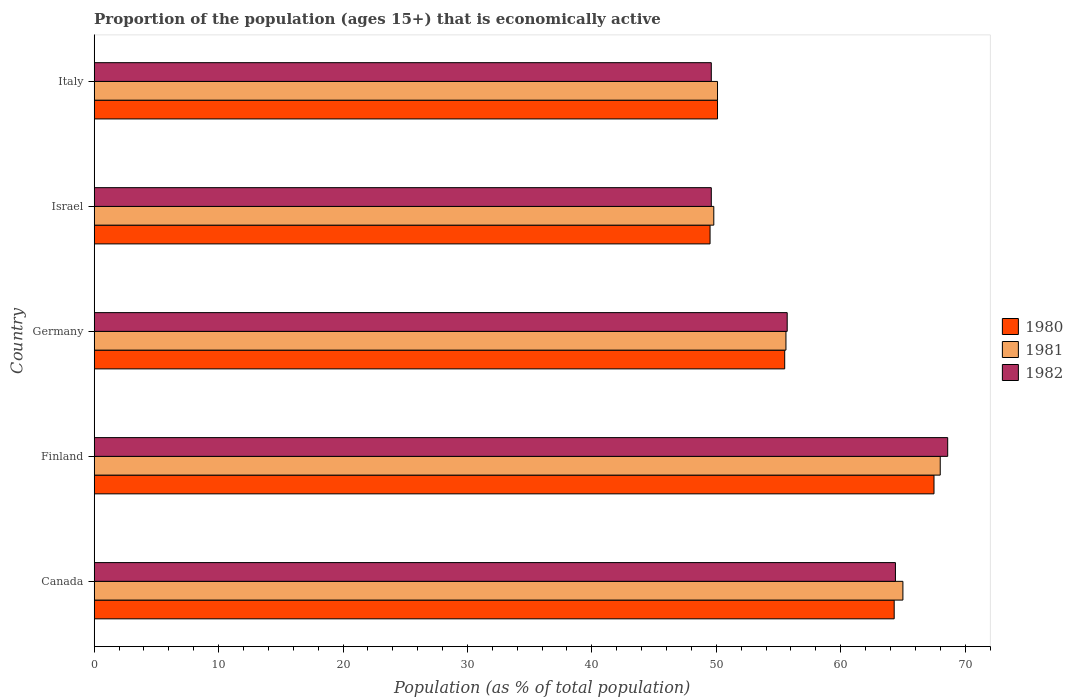How many groups of bars are there?
Provide a short and direct response. 5. Are the number of bars on each tick of the Y-axis equal?
Give a very brief answer. Yes. How many bars are there on the 4th tick from the top?
Offer a very short reply. 3. What is the label of the 1st group of bars from the top?
Keep it short and to the point. Italy. What is the proportion of the population that is economically active in 1980 in Israel?
Your response must be concise. 49.5. Across all countries, what is the minimum proportion of the population that is economically active in 1982?
Provide a succinct answer. 49.6. In which country was the proportion of the population that is economically active in 1980 maximum?
Provide a short and direct response. Finland. In which country was the proportion of the population that is economically active in 1981 minimum?
Make the answer very short. Israel. What is the total proportion of the population that is economically active in 1982 in the graph?
Make the answer very short. 287.9. What is the difference between the proportion of the population that is economically active in 1982 in Canada and the proportion of the population that is economically active in 1981 in Germany?
Your answer should be very brief. 8.8. What is the average proportion of the population that is economically active in 1981 per country?
Make the answer very short. 57.7. What is the difference between the proportion of the population that is economically active in 1982 and proportion of the population that is economically active in 1980 in Israel?
Ensure brevity in your answer.  0.1. What is the ratio of the proportion of the population that is economically active in 1981 in Finland to that in Israel?
Provide a succinct answer. 1.37. Is the difference between the proportion of the population that is economically active in 1982 in Germany and Italy greater than the difference between the proportion of the population that is economically active in 1980 in Germany and Italy?
Ensure brevity in your answer.  Yes. What is the difference between the highest and the second highest proportion of the population that is economically active in 1982?
Offer a very short reply. 4.2. What is the difference between the highest and the lowest proportion of the population that is economically active in 1982?
Keep it short and to the point. 19. How many bars are there?
Ensure brevity in your answer.  15. What is the difference between two consecutive major ticks on the X-axis?
Offer a very short reply. 10. Does the graph contain grids?
Provide a short and direct response. No. Where does the legend appear in the graph?
Make the answer very short. Center right. What is the title of the graph?
Make the answer very short. Proportion of the population (ages 15+) that is economically active. Does "2006" appear as one of the legend labels in the graph?
Offer a terse response. No. What is the label or title of the X-axis?
Offer a terse response. Population (as % of total population). What is the Population (as % of total population) in 1980 in Canada?
Offer a very short reply. 64.3. What is the Population (as % of total population) of 1982 in Canada?
Provide a short and direct response. 64.4. What is the Population (as % of total population) of 1980 in Finland?
Your answer should be very brief. 67.5. What is the Population (as % of total population) of 1981 in Finland?
Your answer should be very brief. 68. What is the Population (as % of total population) of 1982 in Finland?
Your answer should be compact. 68.6. What is the Population (as % of total population) of 1980 in Germany?
Your answer should be compact. 55.5. What is the Population (as % of total population) of 1981 in Germany?
Provide a succinct answer. 55.6. What is the Population (as % of total population) in 1982 in Germany?
Ensure brevity in your answer.  55.7. What is the Population (as % of total population) in 1980 in Israel?
Offer a very short reply. 49.5. What is the Population (as % of total population) in 1981 in Israel?
Offer a terse response. 49.8. What is the Population (as % of total population) of 1982 in Israel?
Offer a very short reply. 49.6. What is the Population (as % of total population) of 1980 in Italy?
Your response must be concise. 50.1. What is the Population (as % of total population) of 1981 in Italy?
Your answer should be compact. 50.1. What is the Population (as % of total population) in 1982 in Italy?
Offer a very short reply. 49.6. Across all countries, what is the maximum Population (as % of total population) in 1980?
Provide a short and direct response. 67.5. Across all countries, what is the maximum Population (as % of total population) of 1981?
Your answer should be very brief. 68. Across all countries, what is the maximum Population (as % of total population) in 1982?
Your answer should be compact. 68.6. Across all countries, what is the minimum Population (as % of total population) in 1980?
Your answer should be very brief. 49.5. Across all countries, what is the minimum Population (as % of total population) of 1981?
Your answer should be compact. 49.8. Across all countries, what is the minimum Population (as % of total population) in 1982?
Offer a very short reply. 49.6. What is the total Population (as % of total population) in 1980 in the graph?
Provide a short and direct response. 286.9. What is the total Population (as % of total population) of 1981 in the graph?
Offer a terse response. 288.5. What is the total Population (as % of total population) of 1982 in the graph?
Your answer should be compact. 287.9. What is the difference between the Population (as % of total population) in 1980 in Canada and that in Finland?
Your response must be concise. -3.2. What is the difference between the Population (as % of total population) of 1981 in Canada and that in Finland?
Offer a terse response. -3. What is the difference between the Population (as % of total population) in 1982 in Canada and that in Finland?
Offer a very short reply. -4.2. What is the difference between the Population (as % of total population) of 1980 in Canada and that in Germany?
Keep it short and to the point. 8.8. What is the difference between the Population (as % of total population) in 1982 in Canada and that in Germany?
Offer a terse response. 8.7. What is the difference between the Population (as % of total population) in 1980 in Canada and that in Israel?
Provide a short and direct response. 14.8. What is the difference between the Population (as % of total population) in 1981 in Canada and that in Israel?
Your answer should be very brief. 15.2. What is the difference between the Population (as % of total population) of 1982 in Canada and that in Israel?
Your answer should be very brief. 14.8. What is the difference between the Population (as % of total population) of 1981 in Canada and that in Italy?
Keep it short and to the point. 14.9. What is the difference between the Population (as % of total population) in 1982 in Canada and that in Italy?
Make the answer very short. 14.8. What is the difference between the Population (as % of total population) in 1980 in Finland and that in Germany?
Make the answer very short. 12. What is the difference between the Population (as % of total population) of 1981 in Finland and that in Germany?
Provide a succinct answer. 12.4. What is the difference between the Population (as % of total population) in 1982 in Finland and that in Germany?
Provide a succinct answer. 12.9. What is the difference between the Population (as % of total population) in 1982 in Finland and that in Israel?
Make the answer very short. 19. What is the difference between the Population (as % of total population) of 1981 in Finland and that in Italy?
Offer a terse response. 17.9. What is the difference between the Population (as % of total population) of 1982 in Finland and that in Italy?
Offer a very short reply. 19. What is the difference between the Population (as % of total population) of 1981 in Germany and that in Italy?
Your answer should be very brief. 5.5. What is the difference between the Population (as % of total population) of 1980 in Israel and that in Italy?
Your answer should be very brief. -0.6. What is the difference between the Population (as % of total population) of 1981 in Israel and that in Italy?
Your answer should be very brief. -0.3. What is the difference between the Population (as % of total population) of 1982 in Israel and that in Italy?
Your answer should be compact. 0. What is the difference between the Population (as % of total population) in 1980 in Canada and the Population (as % of total population) in 1981 in Finland?
Your answer should be compact. -3.7. What is the difference between the Population (as % of total population) in 1980 in Canada and the Population (as % of total population) in 1982 in Germany?
Your answer should be very brief. 8.6. What is the difference between the Population (as % of total population) in 1981 in Canada and the Population (as % of total population) in 1982 in Israel?
Provide a succinct answer. 15.4. What is the difference between the Population (as % of total population) of 1980 in Canada and the Population (as % of total population) of 1982 in Italy?
Your response must be concise. 14.7. What is the difference between the Population (as % of total population) in 1981 in Canada and the Population (as % of total population) in 1982 in Italy?
Provide a short and direct response. 15.4. What is the difference between the Population (as % of total population) of 1980 in Finland and the Population (as % of total population) of 1981 in Germany?
Keep it short and to the point. 11.9. What is the difference between the Population (as % of total population) in 1980 in Finland and the Population (as % of total population) in 1982 in Germany?
Keep it short and to the point. 11.8. What is the difference between the Population (as % of total population) in 1980 in Finland and the Population (as % of total population) in 1981 in Israel?
Your answer should be very brief. 17.7. What is the difference between the Population (as % of total population) of 1980 in Finland and the Population (as % of total population) of 1982 in Israel?
Offer a very short reply. 17.9. What is the difference between the Population (as % of total population) of 1981 in Finland and the Population (as % of total population) of 1982 in Israel?
Your answer should be compact. 18.4. What is the difference between the Population (as % of total population) of 1980 in Germany and the Population (as % of total population) of 1981 in Italy?
Ensure brevity in your answer.  5.4. What is the difference between the Population (as % of total population) of 1980 in Germany and the Population (as % of total population) of 1982 in Italy?
Provide a short and direct response. 5.9. What is the difference between the Population (as % of total population) in 1981 in Germany and the Population (as % of total population) in 1982 in Italy?
Offer a terse response. 6. What is the difference between the Population (as % of total population) of 1980 in Israel and the Population (as % of total population) of 1981 in Italy?
Offer a terse response. -0.6. What is the difference between the Population (as % of total population) of 1980 in Israel and the Population (as % of total population) of 1982 in Italy?
Give a very brief answer. -0.1. What is the difference between the Population (as % of total population) of 1981 in Israel and the Population (as % of total population) of 1982 in Italy?
Your response must be concise. 0.2. What is the average Population (as % of total population) in 1980 per country?
Keep it short and to the point. 57.38. What is the average Population (as % of total population) of 1981 per country?
Keep it short and to the point. 57.7. What is the average Population (as % of total population) in 1982 per country?
Provide a succinct answer. 57.58. What is the difference between the Population (as % of total population) of 1981 and Population (as % of total population) of 1982 in Canada?
Your answer should be compact. 0.6. What is the difference between the Population (as % of total population) in 1981 and Population (as % of total population) in 1982 in Finland?
Give a very brief answer. -0.6. What is the difference between the Population (as % of total population) of 1980 and Population (as % of total population) of 1981 in Germany?
Give a very brief answer. -0.1. What is the difference between the Population (as % of total population) of 1981 and Population (as % of total population) of 1982 in Germany?
Your response must be concise. -0.1. What is the difference between the Population (as % of total population) of 1981 and Population (as % of total population) of 1982 in Israel?
Give a very brief answer. 0.2. What is the difference between the Population (as % of total population) of 1980 and Population (as % of total population) of 1982 in Italy?
Your answer should be very brief. 0.5. What is the difference between the Population (as % of total population) of 1981 and Population (as % of total population) of 1982 in Italy?
Provide a succinct answer. 0.5. What is the ratio of the Population (as % of total population) of 1980 in Canada to that in Finland?
Give a very brief answer. 0.95. What is the ratio of the Population (as % of total population) in 1981 in Canada to that in Finland?
Offer a terse response. 0.96. What is the ratio of the Population (as % of total population) in 1982 in Canada to that in Finland?
Offer a very short reply. 0.94. What is the ratio of the Population (as % of total population) in 1980 in Canada to that in Germany?
Provide a short and direct response. 1.16. What is the ratio of the Population (as % of total population) of 1981 in Canada to that in Germany?
Offer a very short reply. 1.17. What is the ratio of the Population (as % of total population) of 1982 in Canada to that in Germany?
Give a very brief answer. 1.16. What is the ratio of the Population (as % of total population) of 1980 in Canada to that in Israel?
Keep it short and to the point. 1.3. What is the ratio of the Population (as % of total population) in 1981 in Canada to that in Israel?
Make the answer very short. 1.31. What is the ratio of the Population (as % of total population) in 1982 in Canada to that in Israel?
Offer a very short reply. 1.3. What is the ratio of the Population (as % of total population) of 1980 in Canada to that in Italy?
Give a very brief answer. 1.28. What is the ratio of the Population (as % of total population) in 1981 in Canada to that in Italy?
Your answer should be compact. 1.3. What is the ratio of the Population (as % of total population) in 1982 in Canada to that in Italy?
Make the answer very short. 1.3. What is the ratio of the Population (as % of total population) of 1980 in Finland to that in Germany?
Your answer should be compact. 1.22. What is the ratio of the Population (as % of total population) in 1981 in Finland to that in Germany?
Make the answer very short. 1.22. What is the ratio of the Population (as % of total population) of 1982 in Finland to that in Germany?
Give a very brief answer. 1.23. What is the ratio of the Population (as % of total population) in 1980 in Finland to that in Israel?
Make the answer very short. 1.36. What is the ratio of the Population (as % of total population) in 1981 in Finland to that in Israel?
Offer a terse response. 1.37. What is the ratio of the Population (as % of total population) in 1982 in Finland to that in Israel?
Offer a very short reply. 1.38. What is the ratio of the Population (as % of total population) of 1980 in Finland to that in Italy?
Provide a succinct answer. 1.35. What is the ratio of the Population (as % of total population) of 1981 in Finland to that in Italy?
Offer a very short reply. 1.36. What is the ratio of the Population (as % of total population) of 1982 in Finland to that in Italy?
Your answer should be very brief. 1.38. What is the ratio of the Population (as % of total population) in 1980 in Germany to that in Israel?
Give a very brief answer. 1.12. What is the ratio of the Population (as % of total population) of 1981 in Germany to that in Israel?
Ensure brevity in your answer.  1.12. What is the ratio of the Population (as % of total population) in 1982 in Germany to that in Israel?
Make the answer very short. 1.12. What is the ratio of the Population (as % of total population) in 1980 in Germany to that in Italy?
Provide a succinct answer. 1.11. What is the ratio of the Population (as % of total population) of 1981 in Germany to that in Italy?
Offer a terse response. 1.11. What is the ratio of the Population (as % of total population) of 1982 in Germany to that in Italy?
Offer a terse response. 1.12. What is the ratio of the Population (as % of total population) in 1980 in Israel to that in Italy?
Provide a short and direct response. 0.99. What is the ratio of the Population (as % of total population) in 1981 in Israel to that in Italy?
Provide a succinct answer. 0.99. What is the difference between the highest and the second highest Population (as % of total population) in 1980?
Make the answer very short. 3.2. What is the difference between the highest and the second highest Population (as % of total population) in 1981?
Make the answer very short. 3. What is the difference between the highest and the second highest Population (as % of total population) in 1982?
Your response must be concise. 4.2. 